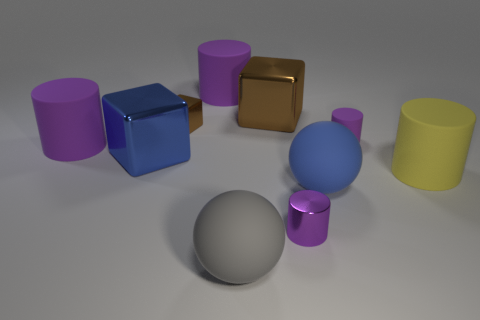Is there any other thing that is the same color as the small metal cylinder? Yes, there is a sphere in the foreground that appears to share the same silver color as the small metal cylinder. 